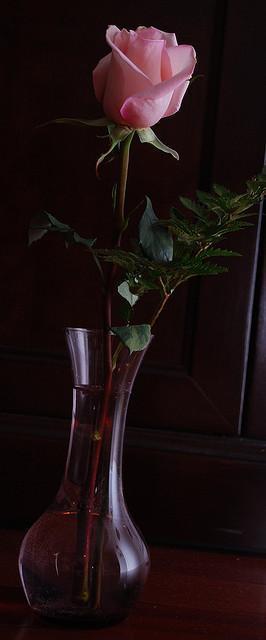How many flowers are there?
Give a very brief answer. 1. How many people are wearing the color blue shirts?
Give a very brief answer. 0. 